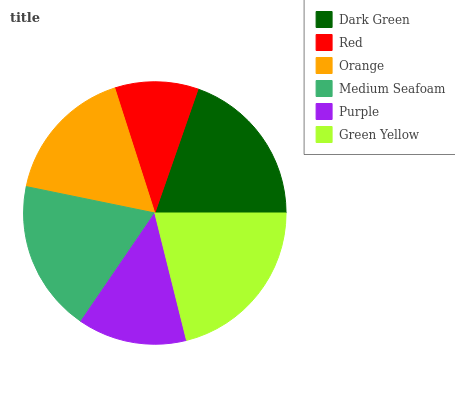Is Red the minimum?
Answer yes or no. Yes. Is Green Yellow the maximum?
Answer yes or no. Yes. Is Orange the minimum?
Answer yes or no. No. Is Orange the maximum?
Answer yes or no. No. Is Orange greater than Red?
Answer yes or no. Yes. Is Red less than Orange?
Answer yes or no. Yes. Is Red greater than Orange?
Answer yes or no. No. Is Orange less than Red?
Answer yes or no. No. Is Medium Seafoam the high median?
Answer yes or no. Yes. Is Orange the low median?
Answer yes or no. Yes. Is Purple the high median?
Answer yes or no. No. Is Purple the low median?
Answer yes or no. No. 